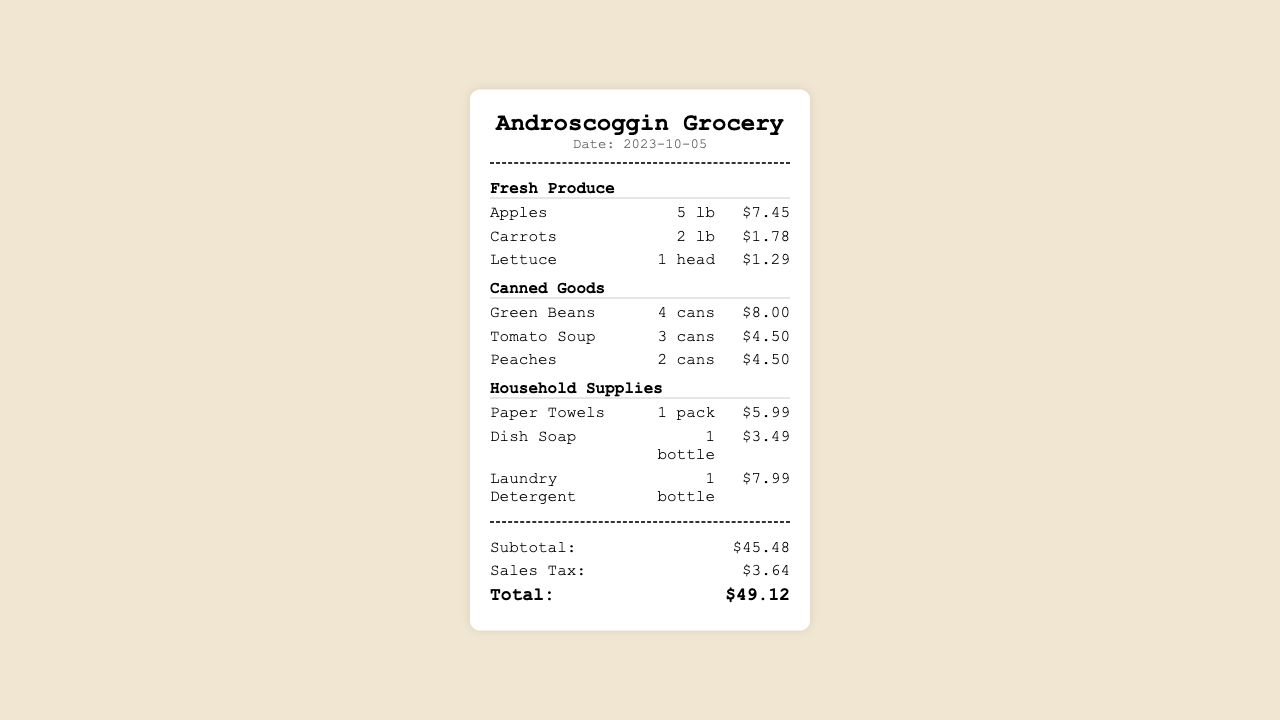What is the date of the grocery purchase? The date of the grocery purchase is mentioned at the top of the receipt.
Answer: 2023-10-05 How much did the apples cost? The price of the apples is listed next to the item in the fresh produce section.
Answer: $7.45 How many cans of tomato soup were purchased? The quantity of tomato soup is specified in the canned goods section of the receipt.
Answer: 3 cans What is the subtotal before tax? The subtotal is calculated based on the sum of all items purchased before adding the sales tax.
Answer: $45.48 What is the total amount paid after tax? The total amount paid includes the subtotal plus sales tax and is found at the bottom of the receipt.
Answer: $49.12 Which item in household supplies is the most expensive? The most expensive item in the household supplies section can be inferred from the pricing listed.
Answer: Laundry Detergent How many pounds of carrots were bought? The quantity of carrots is stated next to the item in the fresh produce category.
Answer: 2 lb What is the sales tax amount? The sales tax amount is specifically mentioned in the totals section of the receipt.
Answer: $3.64 What category does the item "Green Beans" belong to? The category of each item is listed above the items in the receipt.
Answer: Canned Goods 